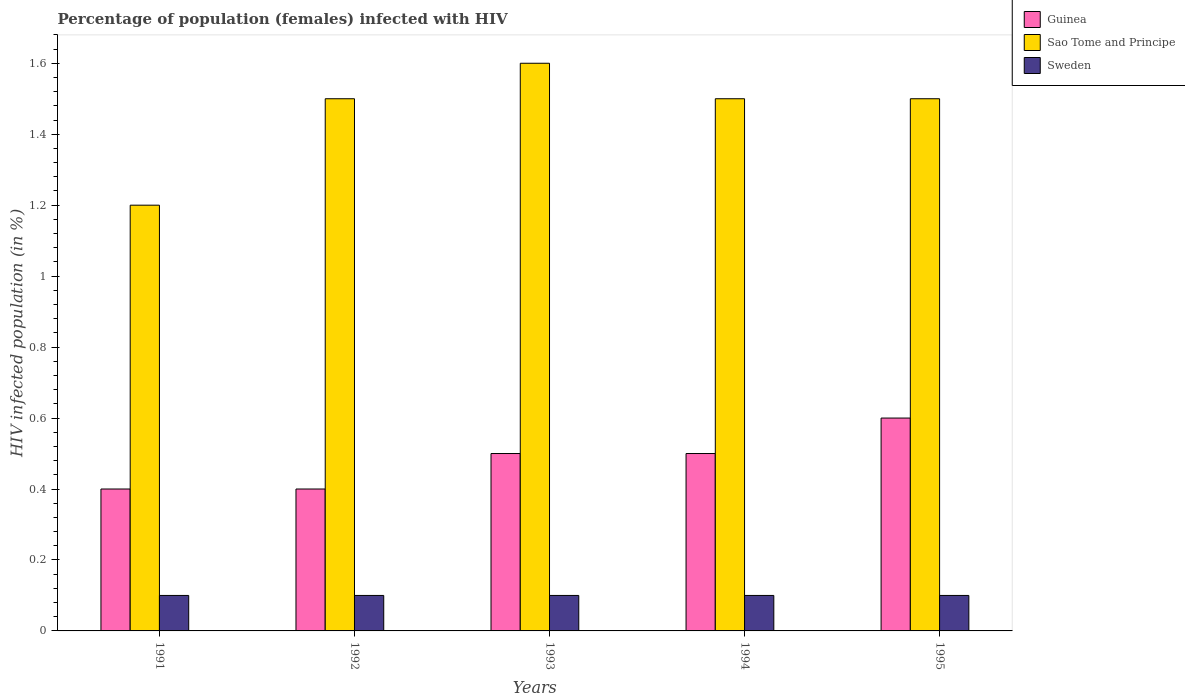How many different coloured bars are there?
Give a very brief answer. 3. Are the number of bars per tick equal to the number of legend labels?
Provide a short and direct response. Yes. Are the number of bars on each tick of the X-axis equal?
Give a very brief answer. Yes. How many bars are there on the 2nd tick from the left?
Your response must be concise. 3. What is the label of the 5th group of bars from the left?
Your response must be concise. 1995. What is the percentage of HIV infected female population in Sao Tome and Principe in 1991?
Offer a terse response. 1.2. Across all years, what is the minimum percentage of HIV infected female population in Sweden?
Offer a terse response. 0.1. In which year was the percentage of HIV infected female population in Sao Tome and Principe maximum?
Make the answer very short. 1993. In which year was the percentage of HIV infected female population in Sao Tome and Principe minimum?
Your answer should be very brief. 1991. What is the total percentage of HIV infected female population in Guinea in the graph?
Provide a short and direct response. 2.4. What is the difference between the percentage of HIV infected female population in Sao Tome and Principe in 1991 and that in 1992?
Ensure brevity in your answer.  -0.3. In the year 1991, what is the difference between the percentage of HIV infected female population in Sao Tome and Principe and percentage of HIV infected female population in Sweden?
Offer a very short reply. 1.1. In how many years, is the percentage of HIV infected female population in Guinea greater than 0.56 %?
Give a very brief answer. 1. What is the ratio of the percentage of HIV infected female population in Guinea in 1993 to that in 1995?
Keep it short and to the point. 0.83. What is the difference between the highest and the second highest percentage of HIV infected female population in Sao Tome and Principe?
Your answer should be compact. 0.1. What is the difference between the highest and the lowest percentage of HIV infected female population in Guinea?
Ensure brevity in your answer.  0.2. What does the 1st bar from the left in 1994 represents?
Offer a terse response. Guinea. What does the 3rd bar from the right in 1992 represents?
Your response must be concise. Guinea. Is it the case that in every year, the sum of the percentage of HIV infected female population in Sweden and percentage of HIV infected female population in Guinea is greater than the percentage of HIV infected female population in Sao Tome and Principe?
Offer a very short reply. No. How many bars are there?
Your response must be concise. 15. Are all the bars in the graph horizontal?
Your answer should be very brief. No. How many years are there in the graph?
Ensure brevity in your answer.  5. What is the difference between two consecutive major ticks on the Y-axis?
Offer a very short reply. 0.2. Are the values on the major ticks of Y-axis written in scientific E-notation?
Offer a terse response. No. Does the graph contain any zero values?
Offer a very short reply. No. Does the graph contain grids?
Your response must be concise. No. Where does the legend appear in the graph?
Offer a very short reply. Top right. How are the legend labels stacked?
Ensure brevity in your answer.  Vertical. What is the title of the graph?
Keep it short and to the point. Percentage of population (females) infected with HIV. Does "United States" appear as one of the legend labels in the graph?
Give a very brief answer. No. What is the label or title of the X-axis?
Provide a succinct answer. Years. What is the label or title of the Y-axis?
Your answer should be compact. HIV infected population (in %). What is the HIV infected population (in %) of Guinea in 1991?
Your response must be concise. 0.4. What is the HIV infected population (in %) in Guinea in 1992?
Keep it short and to the point. 0.4. What is the HIV infected population (in %) of Sweden in 1994?
Provide a succinct answer. 0.1. What is the HIV infected population (in %) of Guinea in 1995?
Keep it short and to the point. 0.6. What is the HIV infected population (in %) of Sao Tome and Principe in 1995?
Your answer should be compact. 1.5. Across all years, what is the maximum HIV infected population (in %) of Sao Tome and Principe?
Ensure brevity in your answer.  1.6. What is the total HIV infected population (in %) in Sao Tome and Principe in the graph?
Provide a short and direct response. 7.3. What is the difference between the HIV infected population (in %) in Sweden in 1991 and that in 1992?
Make the answer very short. 0. What is the difference between the HIV infected population (in %) in Guinea in 1991 and that in 1993?
Make the answer very short. -0.1. What is the difference between the HIV infected population (in %) in Sao Tome and Principe in 1991 and that in 1993?
Make the answer very short. -0.4. What is the difference between the HIV infected population (in %) in Sweden in 1991 and that in 1993?
Provide a short and direct response. 0. What is the difference between the HIV infected population (in %) of Guinea in 1991 and that in 1994?
Your response must be concise. -0.1. What is the difference between the HIV infected population (in %) in Sao Tome and Principe in 1991 and that in 1994?
Offer a terse response. -0.3. What is the difference between the HIV infected population (in %) of Sao Tome and Principe in 1991 and that in 1995?
Offer a very short reply. -0.3. What is the difference between the HIV infected population (in %) in Sweden in 1991 and that in 1995?
Give a very brief answer. 0. What is the difference between the HIV infected population (in %) in Guinea in 1992 and that in 1993?
Provide a short and direct response. -0.1. What is the difference between the HIV infected population (in %) of Guinea in 1992 and that in 1994?
Offer a terse response. -0.1. What is the difference between the HIV infected population (in %) in Sweden in 1992 and that in 1995?
Your answer should be compact. 0. What is the difference between the HIV infected population (in %) of Sao Tome and Principe in 1993 and that in 1994?
Your response must be concise. 0.1. What is the difference between the HIV infected population (in %) of Sweden in 1993 and that in 1994?
Give a very brief answer. 0. What is the difference between the HIV infected population (in %) of Sao Tome and Principe in 1993 and that in 1995?
Your answer should be compact. 0.1. What is the difference between the HIV infected population (in %) in Sweden in 1994 and that in 1995?
Give a very brief answer. 0. What is the difference between the HIV infected population (in %) in Guinea in 1991 and the HIV infected population (in %) in Sweden in 1992?
Make the answer very short. 0.3. What is the difference between the HIV infected population (in %) of Sao Tome and Principe in 1991 and the HIV infected population (in %) of Sweden in 1992?
Offer a very short reply. 1.1. What is the difference between the HIV infected population (in %) in Guinea in 1991 and the HIV infected population (in %) in Sweden in 1993?
Your answer should be very brief. 0.3. What is the difference between the HIV infected population (in %) of Sao Tome and Principe in 1991 and the HIV infected population (in %) of Sweden in 1993?
Your answer should be very brief. 1.1. What is the difference between the HIV infected population (in %) in Guinea in 1991 and the HIV infected population (in %) in Sao Tome and Principe in 1995?
Provide a succinct answer. -1.1. What is the difference between the HIV infected population (in %) of Guinea in 1991 and the HIV infected population (in %) of Sweden in 1995?
Make the answer very short. 0.3. What is the difference between the HIV infected population (in %) of Sao Tome and Principe in 1991 and the HIV infected population (in %) of Sweden in 1995?
Keep it short and to the point. 1.1. What is the difference between the HIV infected population (in %) of Guinea in 1992 and the HIV infected population (in %) of Sao Tome and Principe in 1993?
Keep it short and to the point. -1.2. What is the difference between the HIV infected population (in %) of Guinea in 1992 and the HIV infected population (in %) of Sao Tome and Principe in 1995?
Make the answer very short. -1.1. What is the difference between the HIV infected population (in %) of Sao Tome and Principe in 1992 and the HIV infected population (in %) of Sweden in 1995?
Ensure brevity in your answer.  1.4. What is the difference between the HIV infected population (in %) of Guinea in 1993 and the HIV infected population (in %) of Sao Tome and Principe in 1994?
Provide a short and direct response. -1. What is the difference between the HIV infected population (in %) of Sao Tome and Principe in 1993 and the HIV infected population (in %) of Sweden in 1994?
Offer a terse response. 1.5. What is the difference between the HIV infected population (in %) of Sao Tome and Principe in 1993 and the HIV infected population (in %) of Sweden in 1995?
Offer a terse response. 1.5. What is the difference between the HIV infected population (in %) in Guinea in 1994 and the HIV infected population (in %) in Sweden in 1995?
Ensure brevity in your answer.  0.4. What is the average HIV infected population (in %) of Guinea per year?
Offer a terse response. 0.48. What is the average HIV infected population (in %) in Sao Tome and Principe per year?
Make the answer very short. 1.46. What is the average HIV infected population (in %) in Sweden per year?
Provide a short and direct response. 0.1. In the year 1992, what is the difference between the HIV infected population (in %) in Guinea and HIV infected population (in %) in Sao Tome and Principe?
Give a very brief answer. -1.1. In the year 1992, what is the difference between the HIV infected population (in %) in Guinea and HIV infected population (in %) in Sweden?
Your answer should be very brief. 0.3. In the year 1992, what is the difference between the HIV infected population (in %) of Sao Tome and Principe and HIV infected population (in %) of Sweden?
Offer a very short reply. 1.4. In the year 1993, what is the difference between the HIV infected population (in %) in Guinea and HIV infected population (in %) in Sao Tome and Principe?
Ensure brevity in your answer.  -1.1. In the year 1994, what is the difference between the HIV infected population (in %) of Guinea and HIV infected population (in %) of Sao Tome and Principe?
Your answer should be very brief. -1. In the year 1994, what is the difference between the HIV infected population (in %) in Guinea and HIV infected population (in %) in Sweden?
Offer a terse response. 0.4. In the year 1995, what is the difference between the HIV infected population (in %) of Guinea and HIV infected population (in %) of Sao Tome and Principe?
Offer a terse response. -0.9. What is the ratio of the HIV infected population (in %) of Sao Tome and Principe in 1991 to that in 1992?
Your response must be concise. 0.8. What is the ratio of the HIV infected population (in %) of Guinea in 1991 to that in 1993?
Provide a succinct answer. 0.8. What is the ratio of the HIV infected population (in %) of Guinea in 1991 to that in 1995?
Your answer should be very brief. 0.67. What is the ratio of the HIV infected population (in %) in Sao Tome and Principe in 1991 to that in 1995?
Offer a terse response. 0.8. What is the ratio of the HIV infected population (in %) of Guinea in 1992 to that in 1993?
Ensure brevity in your answer.  0.8. What is the ratio of the HIV infected population (in %) in Guinea in 1992 to that in 1994?
Your response must be concise. 0.8. What is the ratio of the HIV infected population (in %) in Sweden in 1992 to that in 1994?
Provide a succinct answer. 1. What is the ratio of the HIV infected population (in %) of Guinea in 1992 to that in 1995?
Give a very brief answer. 0.67. What is the ratio of the HIV infected population (in %) in Sao Tome and Principe in 1993 to that in 1994?
Provide a succinct answer. 1.07. What is the ratio of the HIV infected population (in %) of Sweden in 1993 to that in 1994?
Give a very brief answer. 1. What is the ratio of the HIV infected population (in %) in Sao Tome and Principe in 1993 to that in 1995?
Keep it short and to the point. 1.07. What is the ratio of the HIV infected population (in %) of Sweden in 1993 to that in 1995?
Provide a succinct answer. 1. What is the ratio of the HIV infected population (in %) in Sao Tome and Principe in 1994 to that in 1995?
Offer a very short reply. 1. What is the ratio of the HIV infected population (in %) of Sweden in 1994 to that in 1995?
Make the answer very short. 1. What is the difference between the highest and the second highest HIV infected population (in %) in Guinea?
Provide a succinct answer. 0.1. What is the difference between the highest and the second highest HIV infected population (in %) in Sweden?
Your response must be concise. 0. What is the difference between the highest and the lowest HIV infected population (in %) of Guinea?
Offer a very short reply. 0.2. What is the difference between the highest and the lowest HIV infected population (in %) in Sao Tome and Principe?
Keep it short and to the point. 0.4. 